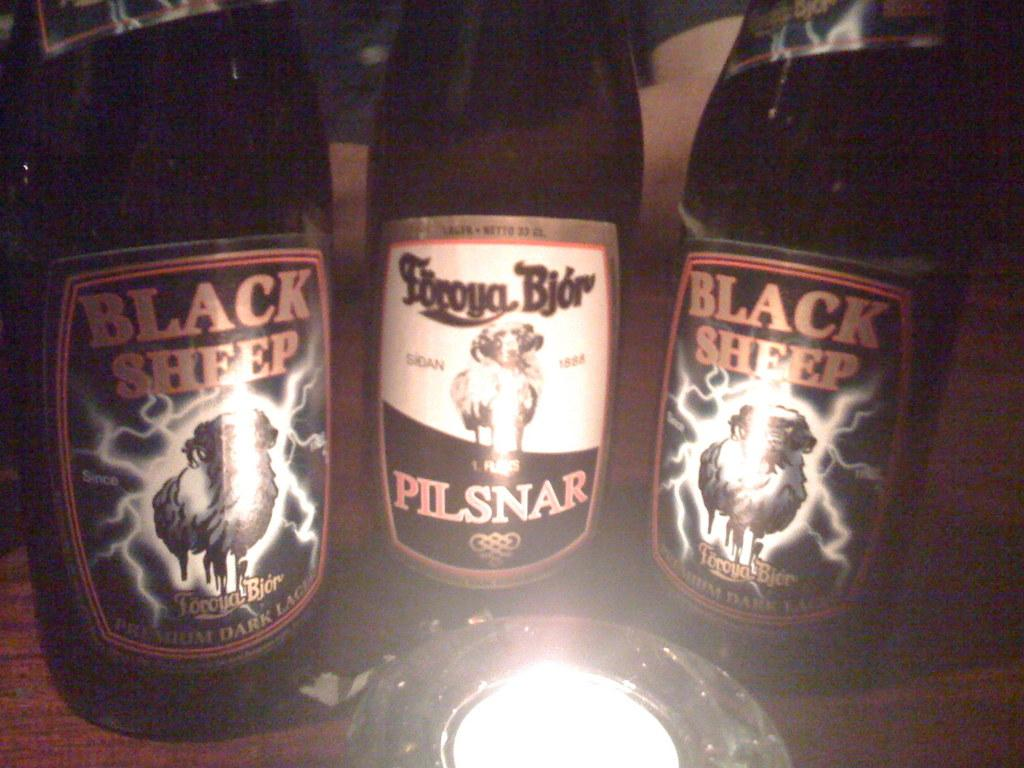Provide a one-sentence caption for the provided image. Pilsnar beer bottle between two Black Sheep beers. 